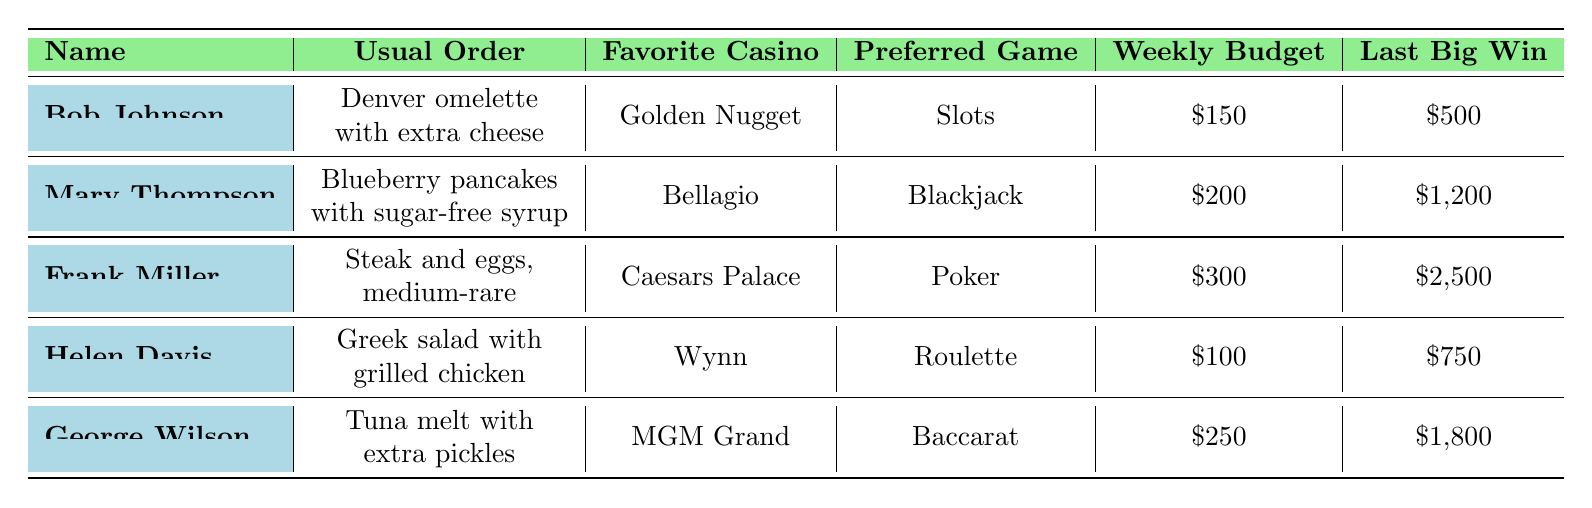What is Bob Johnson's usual order at the diner? According to the table, Bob Johnson's usual order is "Denver omelette with extra cheese."
Answer: Denver omelette with extra cheese How much is Frank Miller's weekly gambling budget? The table shows that Frank Miller has a weekly gambling budget of $300.
Answer: $300 What is the last big win for Mary Thompson? The table indicates that Mary Thompson's last big win was $1,200.
Answer: $1,200 True or False: Helen Davis prefers to play Slots at the casino. The data indicates that Helen Davis prefers to play Roulette, so the statement is false.
Answer: False Which retiree has the highest last big win? By reviewing the last big win amounts, Frank Miller has the highest last big win of $2,500.
Answer: Frank Miller What is the average weekly gambling budget of the retirees? Summing the weekly budgets: 150 + 200 + 300 + 100 + 250 = 1000. There are 5 retirees, so the average is 1000/5 = 200.
Answer: $200 Which retiree has the highest loyalty card level? The loyalty card levels show that Frank Miller has the highest level, which is "Diamond."
Answer: Frank Miller How many retirees gamble at least twice a week? The table indicates that Bob Johnson and Frank Miller both gamble twice a week or more. Therefore, there are 2 retirees in this category.
Answer: 2 What is the total last big win amount for all retirees combined? Adding the last big wins: 500 + 1200 + 2500 + 750 + 1800 = 4750. The total last big win amount is $4,750.
Answer: $4,750 Which game is preferred by George Wilson? According to the information provided, George Wilson prefers to play Baccarat.
Answer: Baccarat 